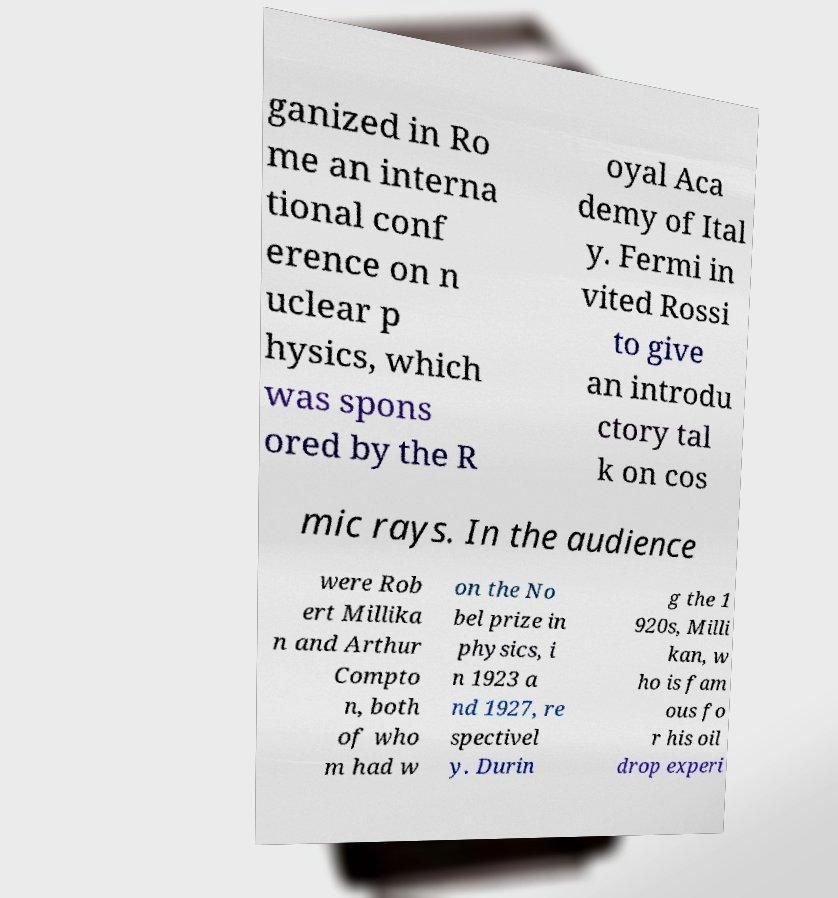For documentation purposes, I need the text within this image transcribed. Could you provide that? ganized in Ro me an interna tional conf erence on n uclear p hysics, which was spons ored by the R oyal Aca demy of Ital y. Fermi in vited Rossi to give an introdu ctory tal k on cos mic rays. In the audience were Rob ert Millika n and Arthur Compto n, both of who m had w on the No bel prize in physics, i n 1923 a nd 1927, re spectivel y. Durin g the 1 920s, Milli kan, w ho is fam ous fo r his oil drop experi 